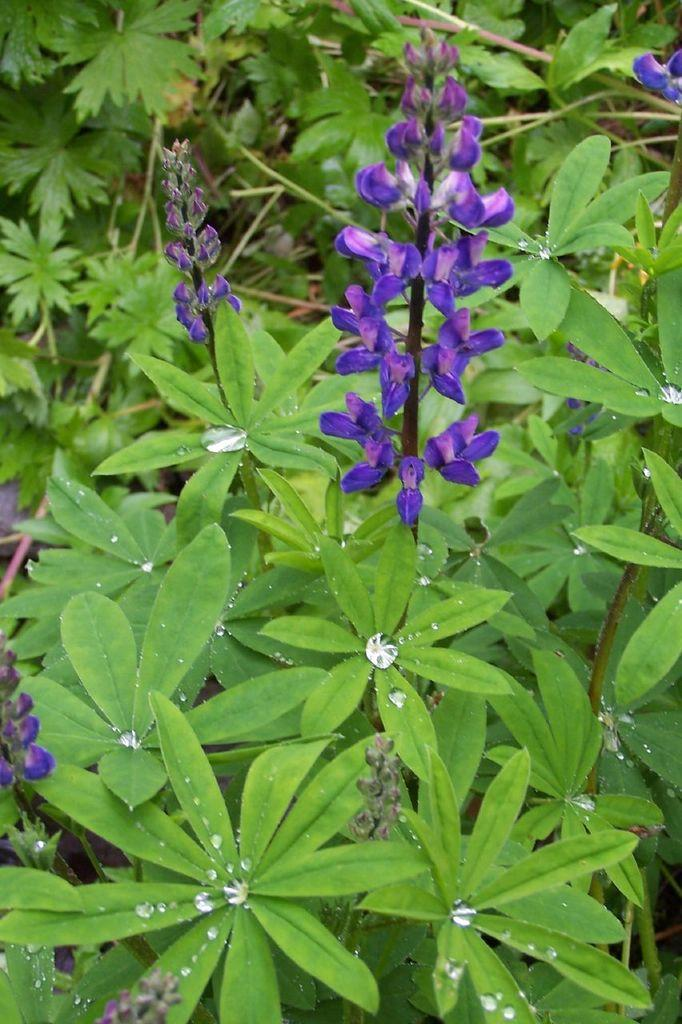What type of living organisms can be seen in the image? Plants can be seen in the image. Can you describe the condition of some leaves in the image? There are water droplets on some leaves in the image. What additional features can be observed on the plants? There are flowers in the image. What color are the flowers? The flowers are violet in color. Can you tell me how many people are swimming in the image? There are no people swimming in the image; it features plants with flowers and water droplets on the leaves. What type of sweater is draped over the flowers in the image? There is no sweater present in the image; it only contains plants, flowers, and water droplets on the leaves. 